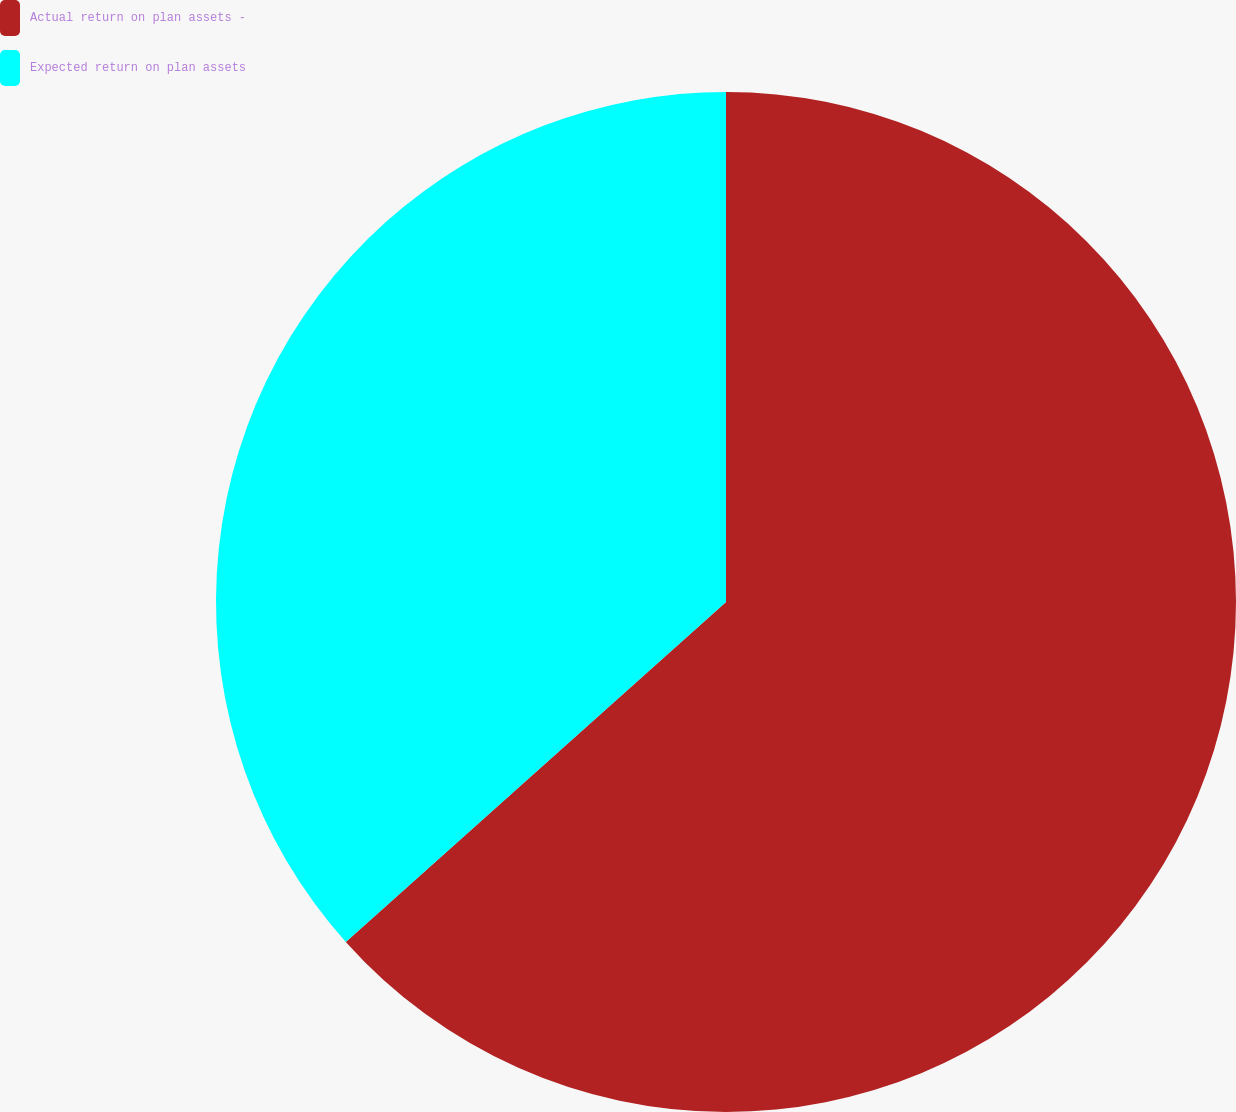<chart> <loc_0><loc_0><loc_500><loc_500><pie_chart><fcel>Actual return on plan assets -<fcel>Expected return on plan assets<nl><fcel>63.39%<fcel>36.61%<nl></chart> 